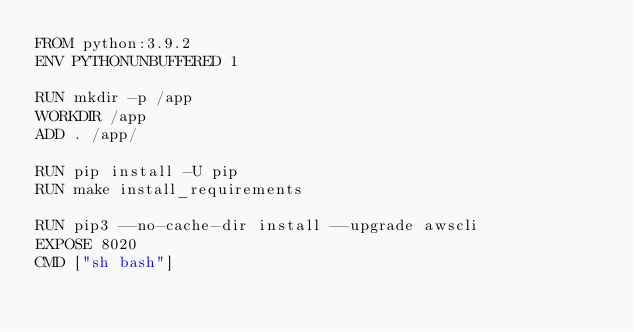Convert code to text. <code><loc_0><loc_0><loc_500><loc_500><_Dockerfile_>FROM python:3.9.2
ENV PYTHONUNBUFFERED 1

RUN mkdir -p /app
WORKDIR /app
ADD . /app/

RUN pip install -U pip
RUN make install_requirements

RUN pip3 --no-cache-dir install --upgrade awscli
EXPOSE 8020
CMD ["sh bash"]
</code> 